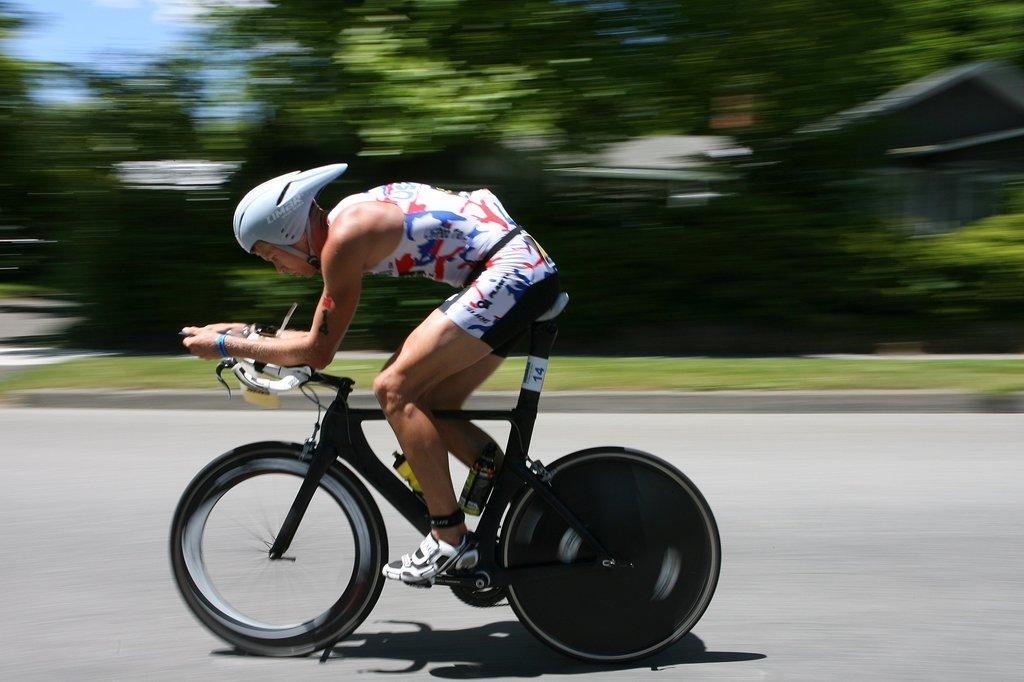Can you describe this image briefly? In the foreground, a person is riding a bicycle, who is wearing ash color helmet. In the background trees are visible and sky visible of blue in color and houses are there. In the middle, grass is visible. This image is taken on the road during day time. 